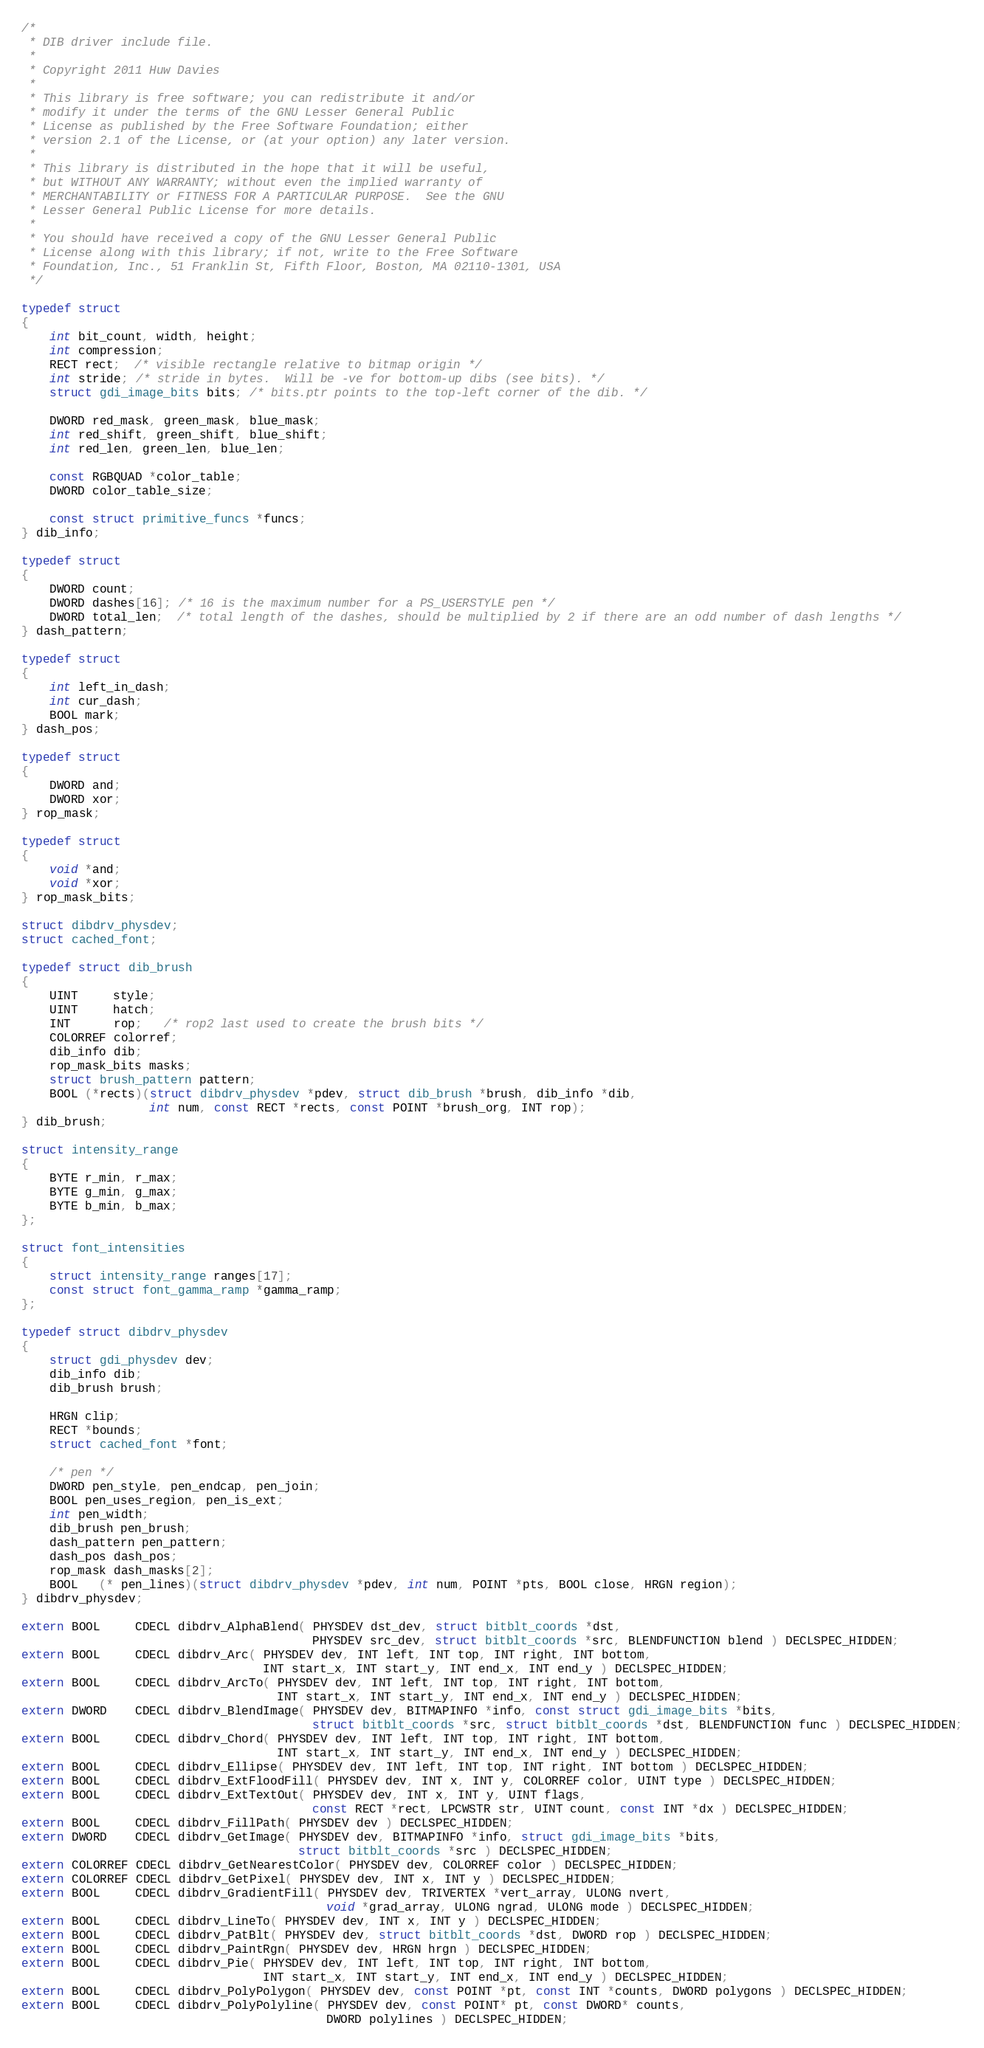<code> <loc_0><loc_0><loc_500><loc_500><_C_>/*
 * DIB driver include file.
 *
 * Copyright 2011 Huw Davies
 *
 * This library is free software; you can redistribute it and/or
 * modify it under the terms of the GNU Lesser General Public
 * License as published by the Free Software Foundation; either
 * version 2.1 of the License, or (at your option) any later version.
 *
 * This library is distributed in the hope that it will be useful,
 * but WITHOUT ANY WARRANTY; without even the implied warranty of
 * MERCHANTABILITY or FITNESS FOR A PARTICULAR PURPOSE.  See the GNU
 * Lesser General Public License for more details.
 *
 * You should have received a copy of the GNU Lesser General Public
 * License along with this library; if not, write to the Free Software
 * Foundation, Inc., 51 Franklin St, Fifth Floor, Boston, MA 02110-1301, USA
 */

typedef struct
{
    int bit_count, width, height;
    int compression;
    RECT rect;  /* visible rectangle relative to bitmap origin */
    int stride; /* stride in bytes.  Will be -ve for bottom-up dibs (see bits). */
    struct gdi_image_bits bits; /* bits.ptr points to the top-left corner of the dib. */

    DWORD red_mask, green_mask, blue_mask;
    int red_shift, green_shift, blue_shift;
    int red_len, green_len, blue_len;

    const RGBQUAD *color_table;
    DWORD color_table_size;

    const struct primitive_funcs *funcs;
} dib_info;

typedef struct
{
    DWORD count;
    DWORD dashes[16]; /* 16 is the maximum number for a PS_USERSTYLE pen */
    DWORD total_len;  /* total length of the dashes, should be multiplied by 2 if there are an odd number of dash lengths */
} dash_pattern;

typedef struct
{
    int left_in_dash;
    int cur_dash;
    BOOL mark;
} dash_pos;

typedef struct
{
    DWORD and;
    DWORD xor;
} rop_mask;

typedef struct
{
    void *and;
    void *xor;
} rop_mask_bits;

struct dibdrv_physdev;
struct cached_font;

typedef struct dib_brush
{
    UINT     style;
    UINT     hatch;
    INT      rop;   /* rop2 last used to create the brush bits */
    COLORREF colorref;
    dib_info dib;
    rop_mask_bits masks;
    struct brush_pattern pattern;
    BOOL (*rects)(struct dibdrv_physdev *pdev, struct dib_brush *brush, dib_info *dib,
                  int num, const RECT *rects, const POINT *brush_org, INT rop);
} dib_brush;

struct intensity_range
{
    BYTE r_min, r_max;
    BYTE g_min, g_max;
    BYTE b_min, b_max;
};

struct font_intensities
{
    struct intensity_range ranges[17];
    const struct font_gamma_ramp *gamma_ramp;
};

typedef struct dibdrv_physdev
{
    struct gdi_physdev dev;
    dib_info dib;
    dib_brush brush;

    HRGN clip;
    RECT *bounds;
    struct cached_font *font;

    /* pen */
    DWORD pen_style, pen_endcap, pen_join;
    BOOL pen_uses_region, pen_is_ext;
    int pen_width;
    dib_brush pen_brush;
    dash_pattern pen_pattern;
    dash_pos dash_pos;
    rop_mask dash_masks[2];
    BOOL   (* pen_lines)(struct dibdrv_physdev *pdev, int num, POINT *pts, BOOL close, HRGN region);
} dibdrv_physdev;

extern BOOL     CDECL dibdrv_AlphaBlend( PHYSDEV dst_dev, struct bitblt_coords *dst,
                                         PHYSDEV src_dev, struct bitblt_coords *src, BLENDFUNCTION blend ) DECLSPEC_HIDDEN;
extern BOOL     CDECL dibdrv_Arc( PHYSDEV dev, INT left, INT top, INT right, INT bottom,
                                  INT start_x, INT start_y, INT end_x, INT end_y ) DECLSPEC_HIDDEN;
extern BOOL     CDECL dibdrv_ArcTo( PHYSDEV dev, INT left, INT top, INT right, INT bottom,
                                    INT start_x, INT start_y, INT end_x, INT end_y ) DECLSPEC_HIDDEN;
extern DWORD    CDECL dibdrv_BlendImage( PHYSDEV dev, BITMAPINFO *info, const struct gdi_image_bits *bits,
                                         struct bitblt_coords *src, struct bitblt_coords *dst, BLENDFUNCTION func ) DECLSPEC_HIDDEN;
extern BOOL     CDECL dibdrv_Chord( PHYSDEV dev, INT left, INT top, INT right, INT bottom,
                                    INT start_x, INT start_y, INT end_x, INT end_y ) DECLSPEC_HIDDEN;
extern BOOL     CDECL dibdrv_Ellipse( PHYSDEV dev, INT left, INT top, INT right, INT bottom ) DECLSPEC_HIDDEN;
extern BOOL     CDECL dibdrv_ExtFloodFill( PHYSDEV dev, INT x, INT y, COLORREF color, UINT type ) DECLSPEC_HIDDEN;
extern BOOL     CDECL dibdrv_ExtTextOut( PHYSDEV dev, INT x, INT y, UINT flags,
                                         const RECT *rect, LPCWSTR str, UINT count, const INT *dx ) DECLSPEC_HIDDEN;
extern BOOL     CDECL dibdrv_FillPath( PHYSDEV dev ) DECLSPEC_HIDDEN;
extern DWORD    CDECL dibdrv_GetImage( PHYSDEV dev, BITMAPINFO *info, struct gdi_image_bits *bits,
                                       struct bitblt_coords *src ) DECLSPEC_HIDDEN;
extern COLORREF CDECL dibdrv_GetNearestColor( PHYSDEV dev, COLORREF color ) DECLSPEC_HIDDEN;
extern COLORREF CDECL dibdrv_GetPixel( PHYSDEV dev, INT x, INT y ) DECLSPEC_HIDDEN;
extern BOOL     CDECL dibdrv_GradientFill( PHYSDEV dev, TRIVERTEX *vert_array, ULONG nvert,
                                           void *grad_array, ULONG ngrad, ULONG mode ) DECLSPEC_HIDDEN;
extern BOOL     CDECL dibdrv_LineTo( PHYSDEV dev, INT x, INT y ) DECLSPEC_HIDDEN;
extern BOOL     CDECL dibdrv_PatBlt( PHYSDEV dev, struct bitblt_coords *dst, DWORD rop ) DECLSPEC_HIDDEN;
extern BOOL     CDECL dibdrv_PaintRgn( PHYSDEV dev, HRGN hrgn ) DECLSPEC_HIDDEN;
extern BOOL     CDECL dibdrv_Pie( PHYSDEV dev, INT left, INT top, INT right, INT bottom,
                                  INT start_x, INT start_y, INT end_x, INT end_y ) DECLSPEC_HIDDEN;
extern BOOL     CDECL dibdrv_PolyPolygon( PHYSDEV dev, const POINT *pt, const INT *counts, DWORD polygons ) DECLSPEC_HIDDEN;
extern BOOL     CDECL dibdrv_PolyPolyline( PHYSDEV dev, const POINT* pt, const DWORD* counts,
                                           DWORD polylines ) DECLSPEC_HIDDEN;</code> 